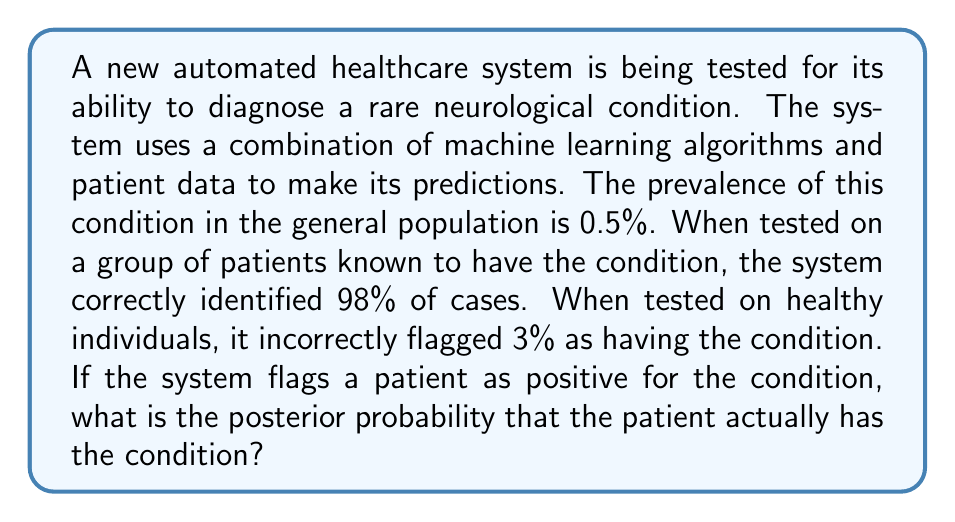Show me your answer to this math problem. To solve this problem, we'll use Bayes' theorem, which is fundamental in calculating posterior probabilities. Let's define our events:

A: The patient has the condition
B: The system flags the patient as positive

We need to calculate P(A|B), which is the probability that the patient has the condition given that the system flagged them as positive.

Bayes' theorem states:

$$ P(A|B) = \frac{P(B|A) \cdot P(A)}{P(B)} $$

Let's break down each component:

1. P(A) = 0.005 (prevalence of the condition, 0.5%)
2. P(B|A) = 0.98 (sensitivity of the test, true positive rate)
3. P(B) = P(B|A) · P(A) + P(B|not A) · P(not A)

To calculate P(B), we need:
- P(not A) = 1 - P(A) = 0.995
- P(B|not A) = 0.03 (false positive rate)

Now we can calculate P(B):

$$ P(B) = 0.98 \cdot 0.005 + 0.03 \cdot 0.995 = 0.0049 + 0.02985 = 0.03475 $$

Plugging everything into Bayes' theorem:

$$ P(A|B) = \frac{0.98 \cdot 0.005}{0.03475} = \frac{0.0049}{0.03475} \approx 0.1410 $$

Therefore, the posterior probability that the patient has the condition, given a positive flag from the system, is approximately 0.1410 or 14.10%.
Answer: The posterior probability that the patient has the condition, given a positive flag from the automated healthcare system, is approximately 0.1410 or 14.10%. 